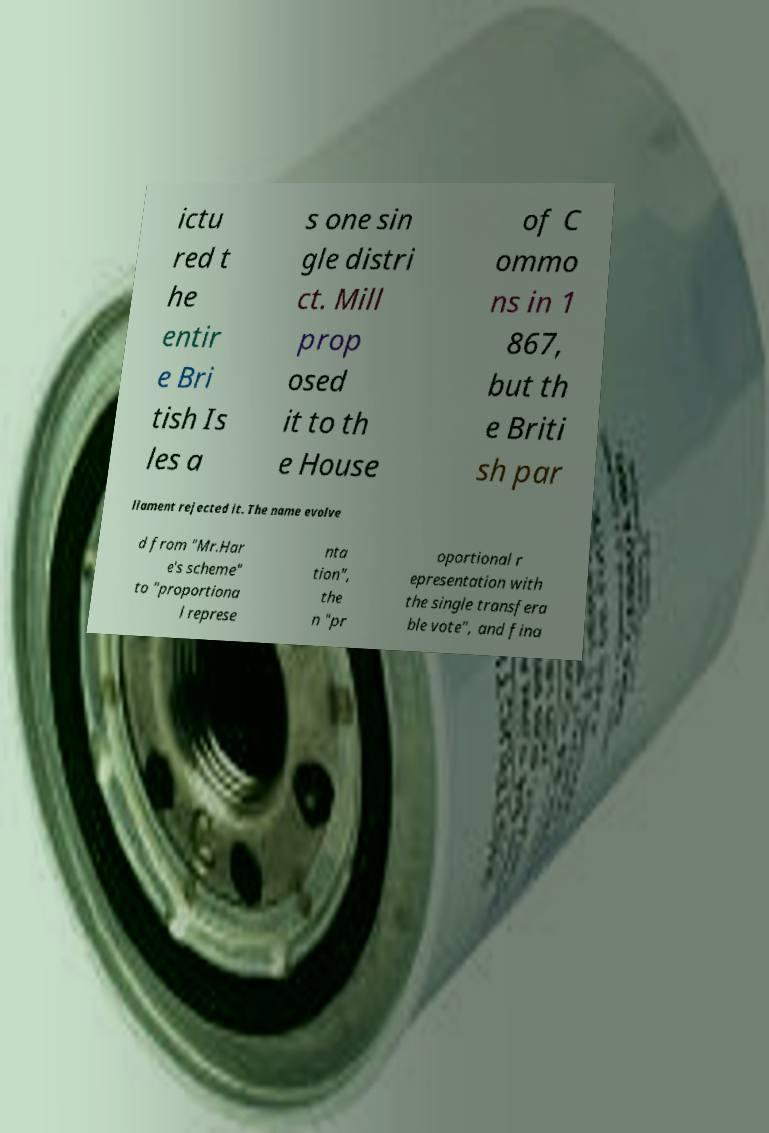I need the written content from this picture converted into text. Can you do that? ictu red t he entir e Bri tish Is les a s one sin gle distri ct. Mill prop osed it to th e House of C ommo ns in 1 867, but th e Briti sh par liament rejected it. The name evolve d from "Mr.Har e's scheme" to "proportiona l represe nta tion", the n "pr oportional r epresentation with the single transfera ble vote", and fina 